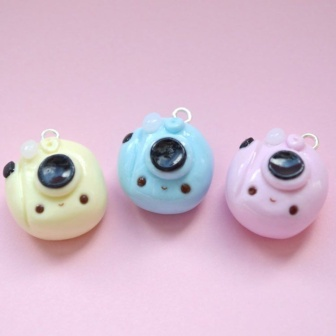If these charms were part of a magical world, what role would they play? In a magical world, these bird-shaped charms would be guardians of the Enchanted Forest, each possessing a unique ability tied to their color. Chirpy, the yellow charm, would control the sunlight, able to bring warmth and light to even the darkest corners. Blu, the blue charm, could summon rain and control water, ensuring the forest always had fresh and pure streams. Rosy, the pink charm, would have the power to make flowers bloom, spreading beauty and fragrance wherever she went. Together, they would maintain the balance of nature, protecting their enchanted realm with their harmonious powers, ensuring that magic and wonder thrived in their enchanted home. Can you write a poem about these adorable bird-shaped charms? In a world of pastel dreams, three charms delight, 
Chirpy in yellow, sings with all her might. 
Blu in blue, loves the rain's gentle fall, 
Rosy in pink, blooms beauty for all. 
Together they dance, in harmony and glee, 
Guardians of magic, wild and free. 
From sunny days to rainy nights, 
Their bond shines ever so bright. 
Little loops atop, they hang with grace, 
Making the world a lovelier place. 